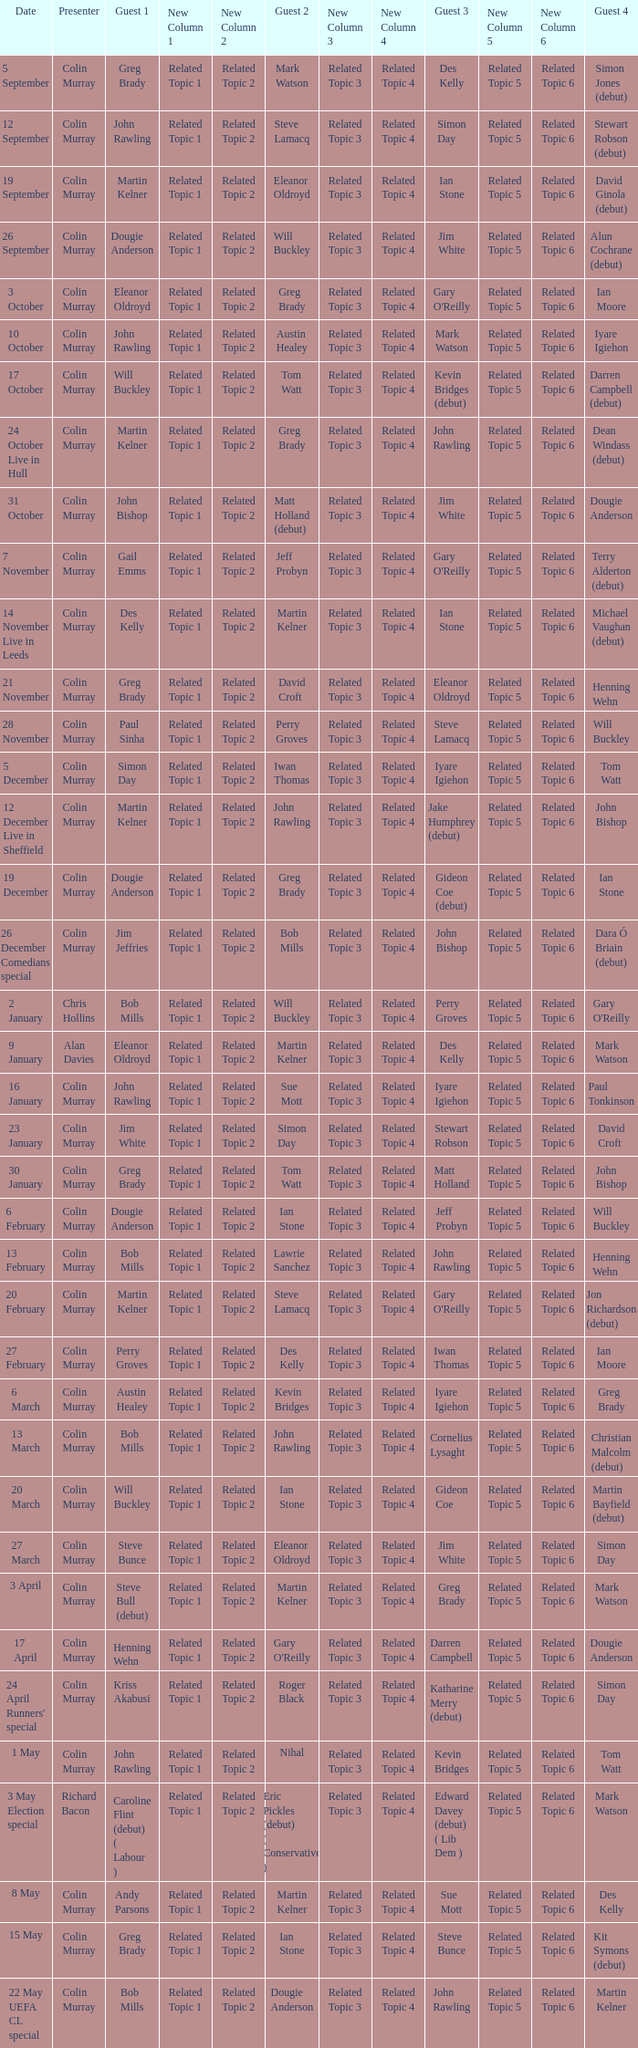How many people are guest 1 on episodes where guest 4 is Des Kelly? 1.0. 